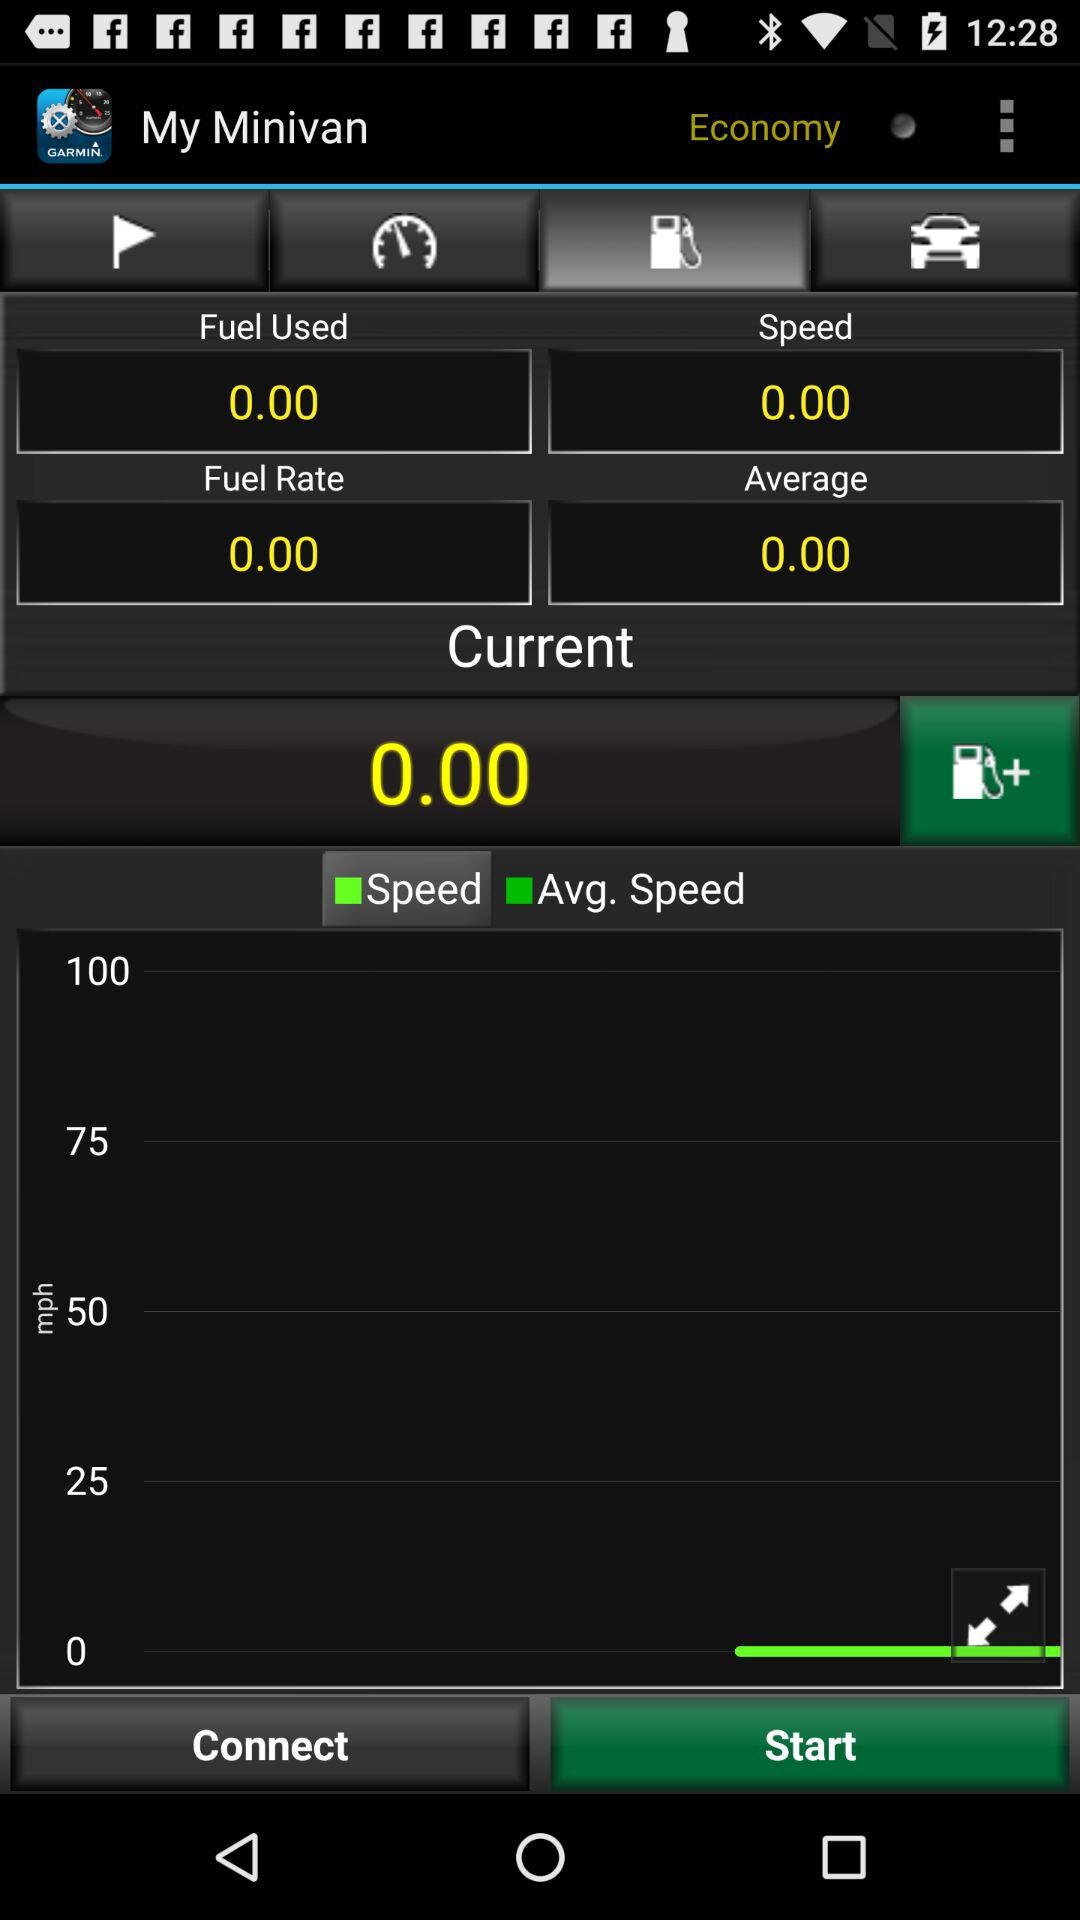What is the application name? The application name is "Garmin Mechanic™". 